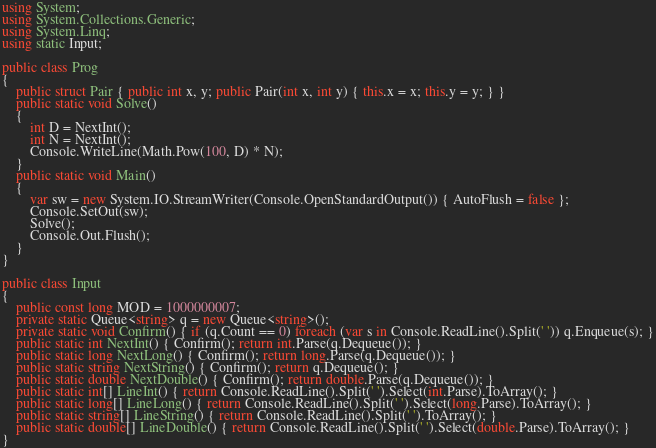<code> <loc_0><loc_0><loc_500><loc_500><_C#_>using System;
using System.Collections.Generic;
using System.Linq;
using static Input;

public class Prog
{
    public struct Pair { public int x, y; public Pair(int x, int y) { this.x = x; this.y = y; } }
    public static void Solve()
    {
        int D = NextInt();
        int N = NextInt();
        Console.WriteLine(Math.Pow(100, D) * N);
    }
    public static void Main()
    {
        var sw = new System.IO.StreamWriter(Console.OpenStandardOutput()) { AutoFlush = false };
        Console.SetOut(sw);
        Solve();
        Console.Out.Flush();
    }
}

public class Input
{
    public const long MOD = 1000000007;
    private static Queue<string> q = new Queue<string>();
    private static void Confirm() { if (q.Count == 0) foreach (var s in Console.ReadLine().Split(' ')) q.Enqueue(s); }
    public static int NextInt() { Confirm(); return int.Parse(q.Dequeue()); }
    public static long NextLong() { Confirm(); return long.Parse(q.Dequeue()); }
    public static string NextString() { Confirm(); return q.Dequeue(); }
    public static double NextDouble() { Confirm(); return double.Parse(q.Dequeue()); }
    public static int[] LineInt() { return Console.ReadLine().Split(' ').Select(int.Parse).ToArray(); }
    public static long[] LineLong() { return Console.ReadLine().Split(' ').Select(long.Parse).ToArray(); }
    public static string[] LineString() { return Console.ReadLine().Split(' ').ToArray(); }
    public static double[] LineDouble() { return Console.ReadLine().Split(' ').Select(double.Parse).ToArray(); }
}
</code> 